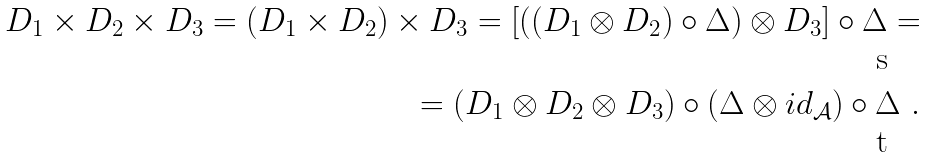Convert formula to latex. <formula><loc_0><loc_0><loc_500><loc_500>D _ { 1 } \times D _ { 2 } \times D _ { 3 } = ( D _ { 1 } \times D _ { 2 } ) \times D _ { 3 } = [ ( ( D _ { 1 } \otimes D _ { 2 } ) \circ \Delta ) \otimes D _ { 3 } ] \circ \Delta = \\ = ( D _ { 1 } \otimes D _ { 2 } \otimes D _ { 3 } ) \circ ( \Delta \otimes i d _ { \mathcal { A } } ) \circ \Delta \ .</formula> 